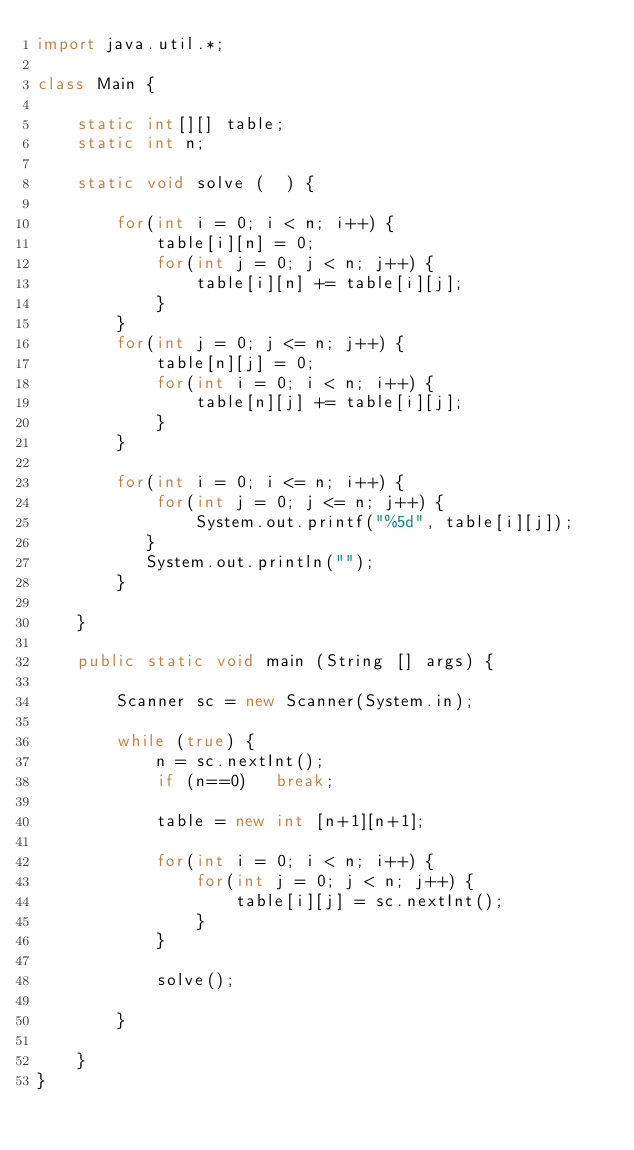Convert code to text. <code><loc_0><loc_0><loc_500><loc_500><_Java_>import java.util.*;

class Main {

    static int[][] table;
    static int n;

    static void solve (  ) {

        for(int i = 0; i < n; i++) {
            table[i][n] = 0;
            for(int j = 0; j < n; j++) {
                table[i][n] += table[i][j];
            }
        }
        for(int j = 0; j <= n; j++) {
            table[n][j] = 0;
            for(int i = 0; i < n; i++) {
                table[n][j] += table[i][j];
            }
        }

        for(int i = 0; i <= n; i++) {
            for(int j = 0; j <= n; j++) {
                System.out.printf("%5d", table[i][j]);
           }
           System.out.println("");
        }

    }

    public static void main (String [] args) {

        Scanner sc = new Scanner(System.in);

        while (true) {
            n = sc.nextInt();
            if (n==0)   break;

            table = new int [n+1][n+1];

            for(int i = 0; i < n; i++) {
                for(int j = 0; j < n; j++) {
                    table[i][j] = sc.nextInt();
                }
            }

            solve();

        }

    }
}</code> 